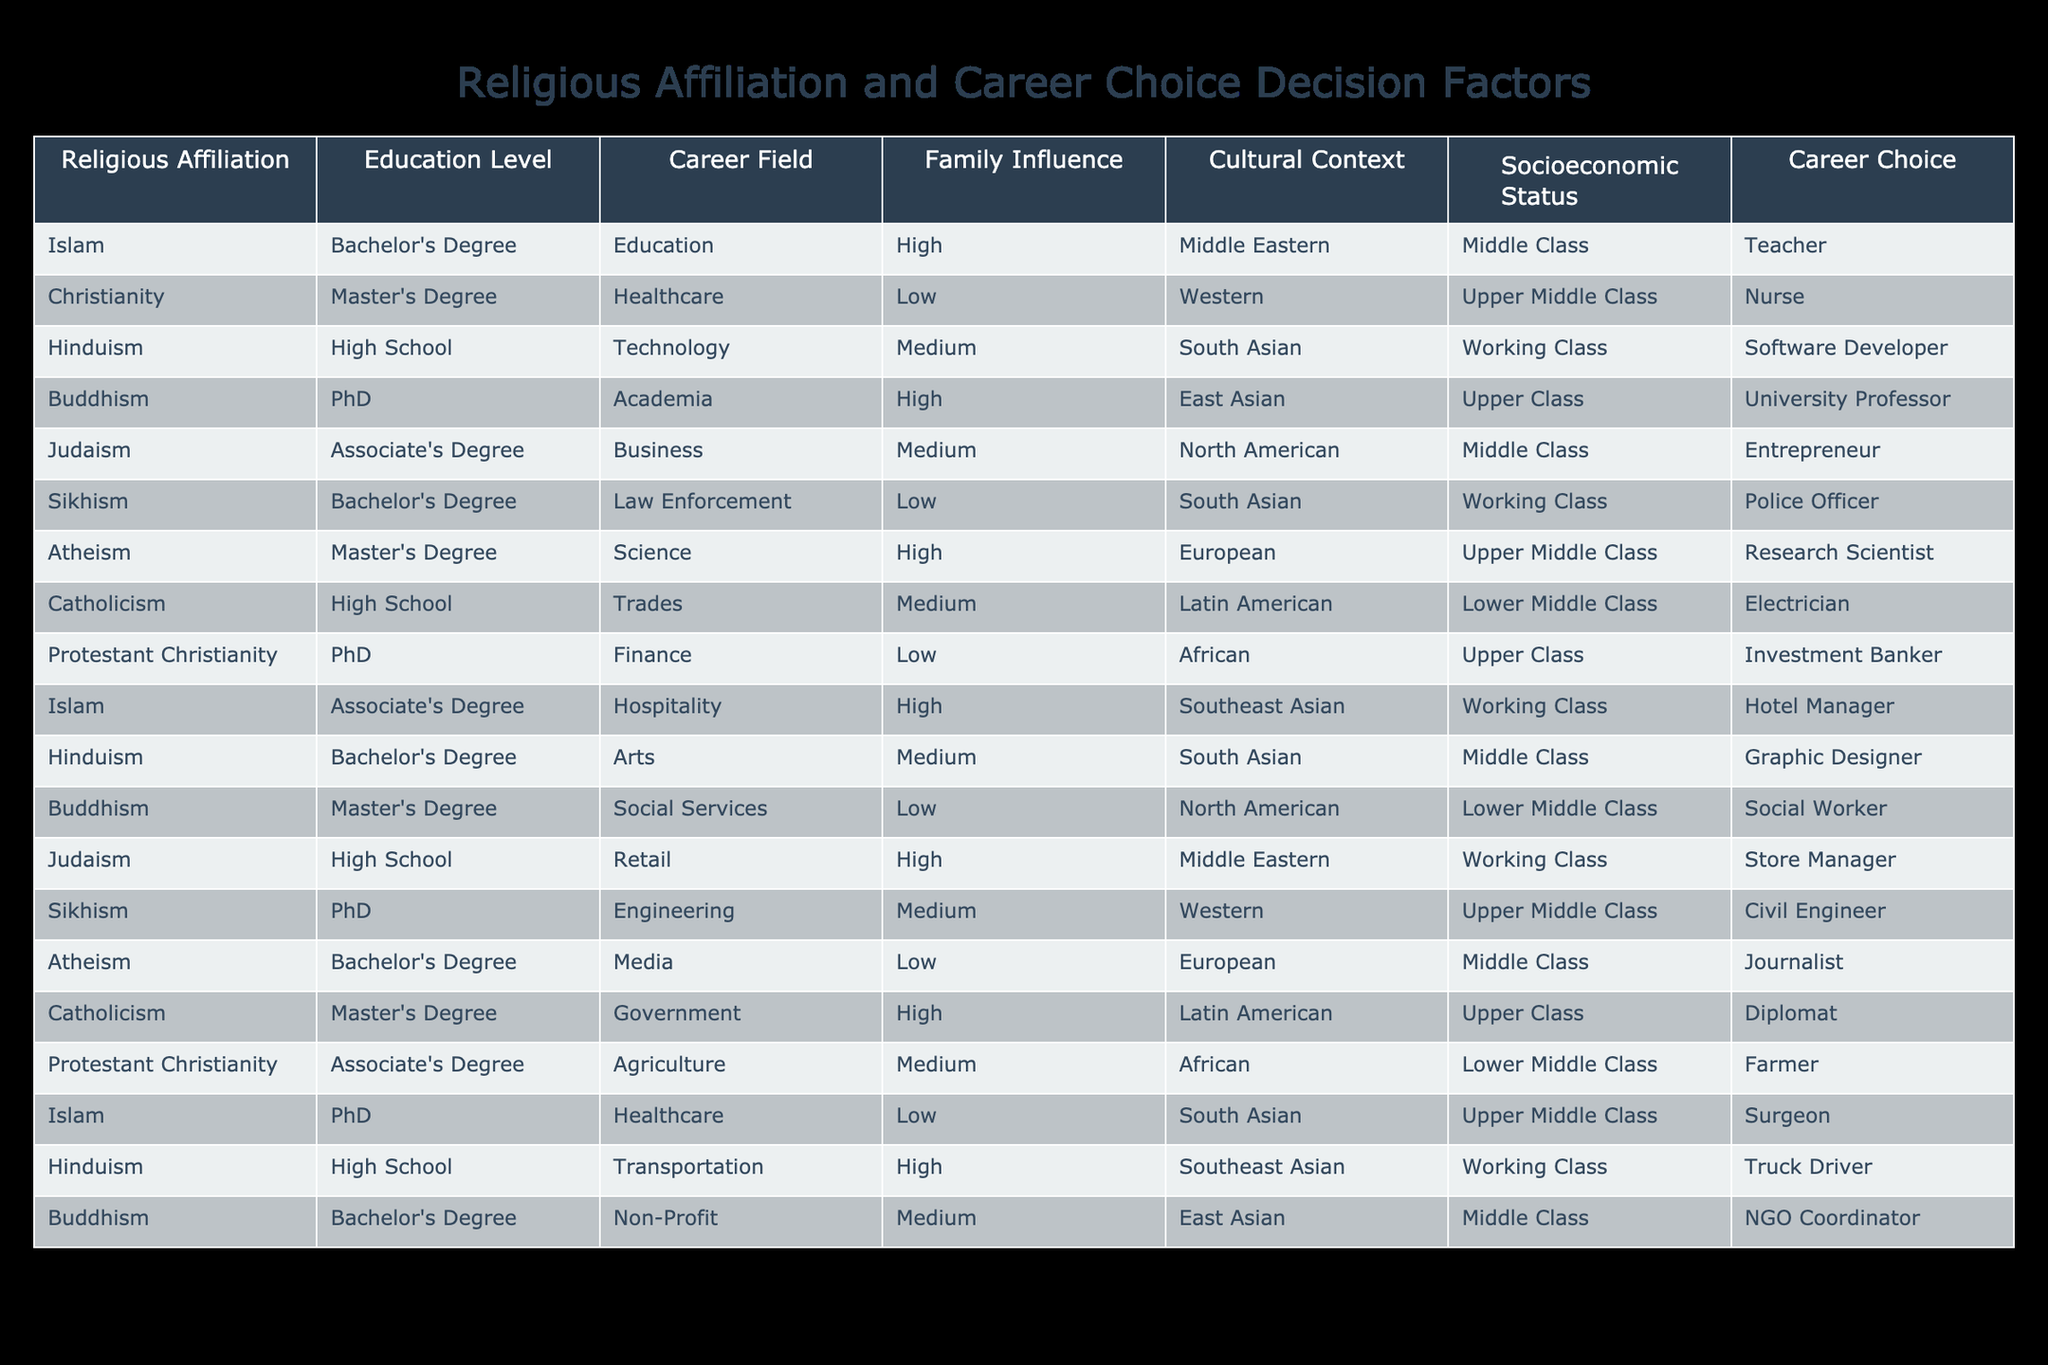What is the career choice for individuals affiliated with Judaism? Referring to the table, individuals with a Jewish affiliation have the career choice of an Entrepreneur, based on their educational level of an Associate's Degree.
Answer: Entrepreneur Which religious affiliation has the highest socioeconomic status represented in the table? The table shows that individuals with Buddhism have an Upper Class socioeconomic status, which is the highest among the listed affiliations.
Answer: Buddhism Is there a relationship between education level and career field for those who identify as Buddhists? Yes, Buddhists in the table have varied education levels, including a PhD (University Professor), Master's Degree (Social Services), and Bachelor's Degree (Non-Profit). This indicates multiple career fields based on different educational attainments.
Answer: Yes What is the average education level of career choices related to the healthcare field? By identifying relevant rows, we have two healthcare-related careers: Nurse with a Master's Degree (2 years) and Surgeon with a PhD (6 years). Adding the years of education gives us 2 + 6 = 8 years, then dividing by 2 sends us to an average of 4 years.
Answer: 4 years Which socio-economic status has the majority of career choices associated with Sikhism? Looking at the table, we note that Sikhism has career choices associated with Working Class (Police Officer) and Upper Middle Class (Civil Engineer). The majority reflects the first category: Working Class.
Answer: Working Class Do individuals with Atheism have a higher career choice in Science or Media? In the table, Atheism has career choices listed as Research Scientist (Science) and Journalist (Media). A clear answer can be drawn based on counting the occurrence of each as just one for each.
Answer: They are equal What are the career choices for individuals with a Bachelor's Degree in the table? From the table, the career choices for individuals with a Bachelor's Degree include Teacher (Islam), Software Developer (Hinduism), Graphic Designer (Hinduism), and Journalist (Atheism), which amounts to four distinct careers.
Answer: 4 Does family influence appear to be high for those pursuing a career in education? Yes, the table indicates that the career choice for Teacher (Islam) has a high family influence, confirming that family exerted a significant influence in this case.
Answer: Yes How many individuals in the table are from a Middle Class socioeconomic status? To find the count, we analyze each row for individuals falling under the Middle Class category: Teacher (Islam), Entrepreneur (Judaism), Graphic Designer (Hinduism), and Journalist (Atheism), making a total of four.
Answer: 4 